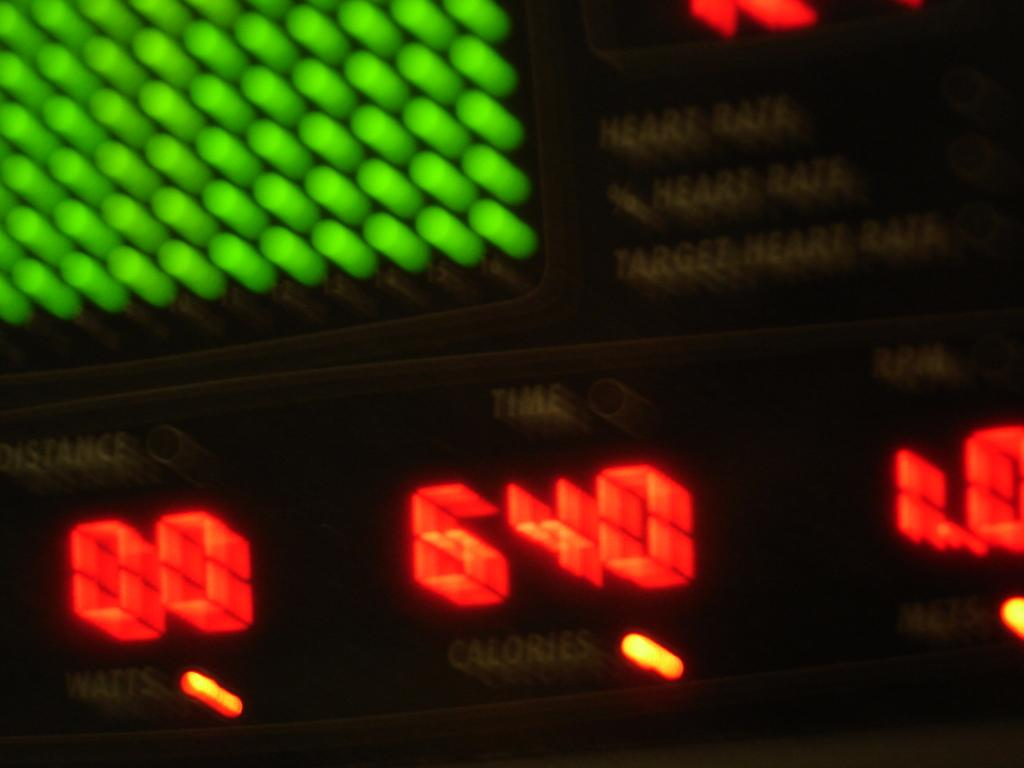What is the main object in the image? There is a measuring meter in the image. What additional information is provided with the measuring meter? There is text associated with the measuring meter. Can you describe the text on the measuring meter? The text includes a lightning symbol. What type of brush is used to apply butter on the measuring meter in the image? There is no brush or butter present in the image; it features a measuring meter with text that includes a lightning symbol. 